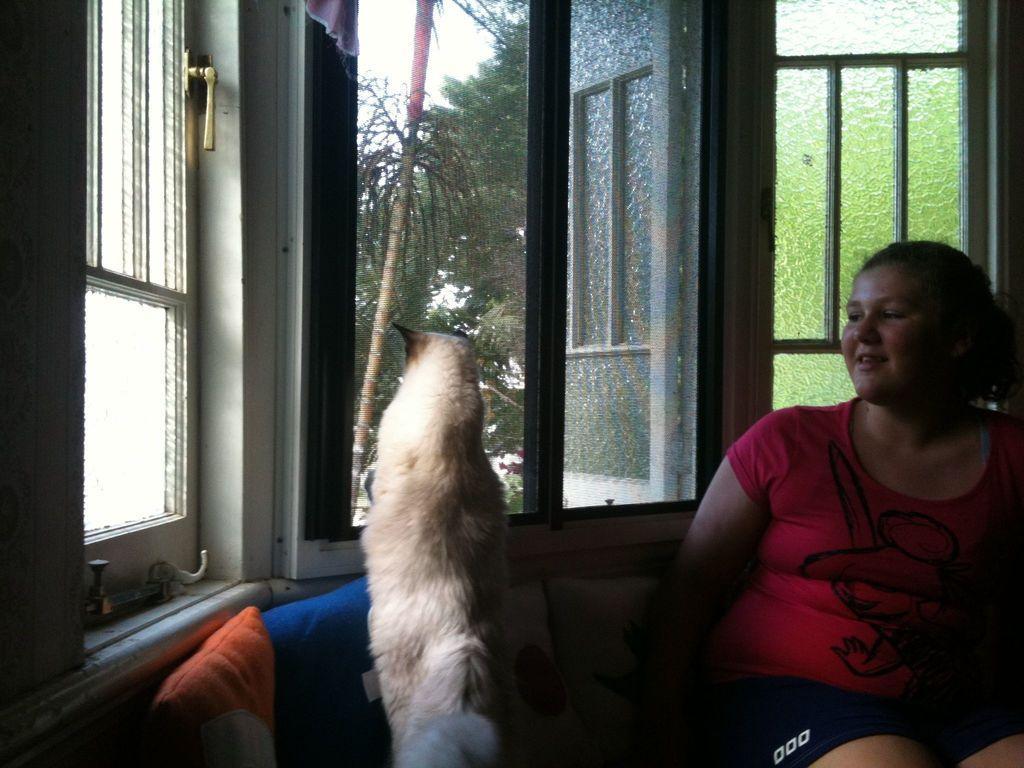Describe this image in one or two sentences. There is a lady sitting on the right side of the image, it seems like a cat in the center, there are pillows at the bottom side and there are windows, trees and sky in the background area. 